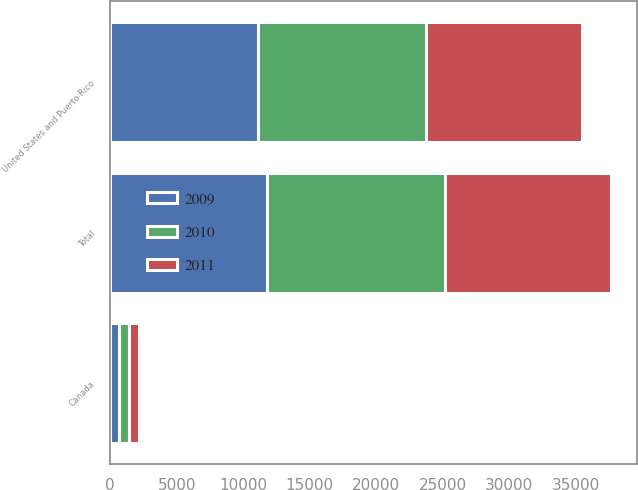<chart> <loc_0><loc_0><loc_500><loc_500><stacked_bar_chart><ecel><fcel>United States and Puerto Rico<fcel>Canada<fcel>Total<nl><fcel>2010<fcel>12578<fcel>800<fcel>13378<nl><fcel>2011<fcel>11784<fcel>731<fcel>12515<nl><fcel>2009<fcel>11137<fcel>654<fcel>11791<nl></chart> 